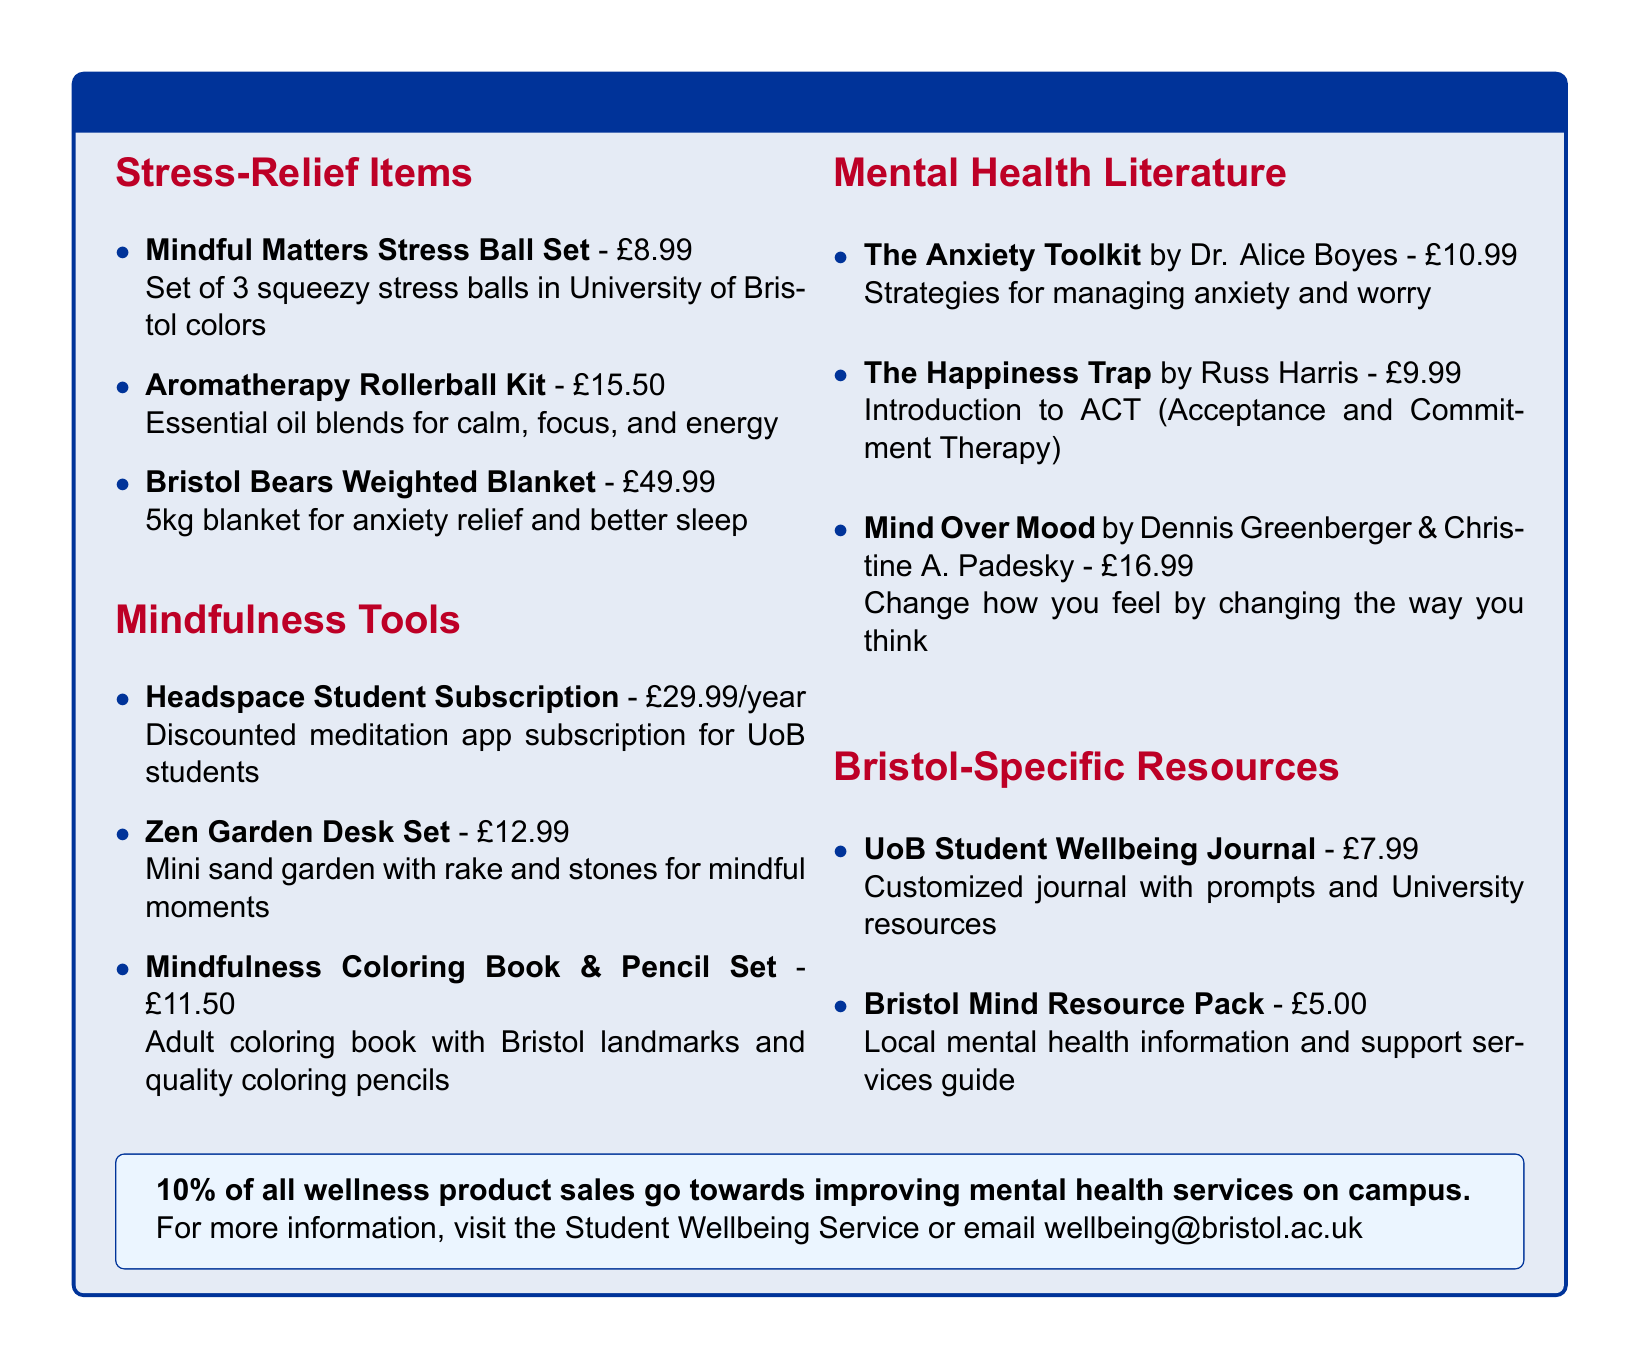what is the price of the Mindful Matters Stress Ball Set? The price is listed under the Stress-Relief Items section next to the product name.
Answer: £8.99 how many items are included in the Aromatherapy Rollerball Kit? The description states that it includes essential oil blends, but doesn't provide a specific count of items. It can be inferred that it is a set of multiple blends.
Answer: Multiple blends who is the author of "Mind Over Mood"? The author's name can be found next to the book title in the Mental Health Literature section.
Answer: Dennis Greenberger & Christine A. Padesky what is the purpose of the UoB Student Wellbeing Journal? This information is provided in the description of the journal under the Bristol-Specific Resources section.
Answer: Customized journal with prompts how much of the sales from wellness products goes towards mental health services? This information is noted in the promotional box at the bottom of the document.
Answer: 10% 